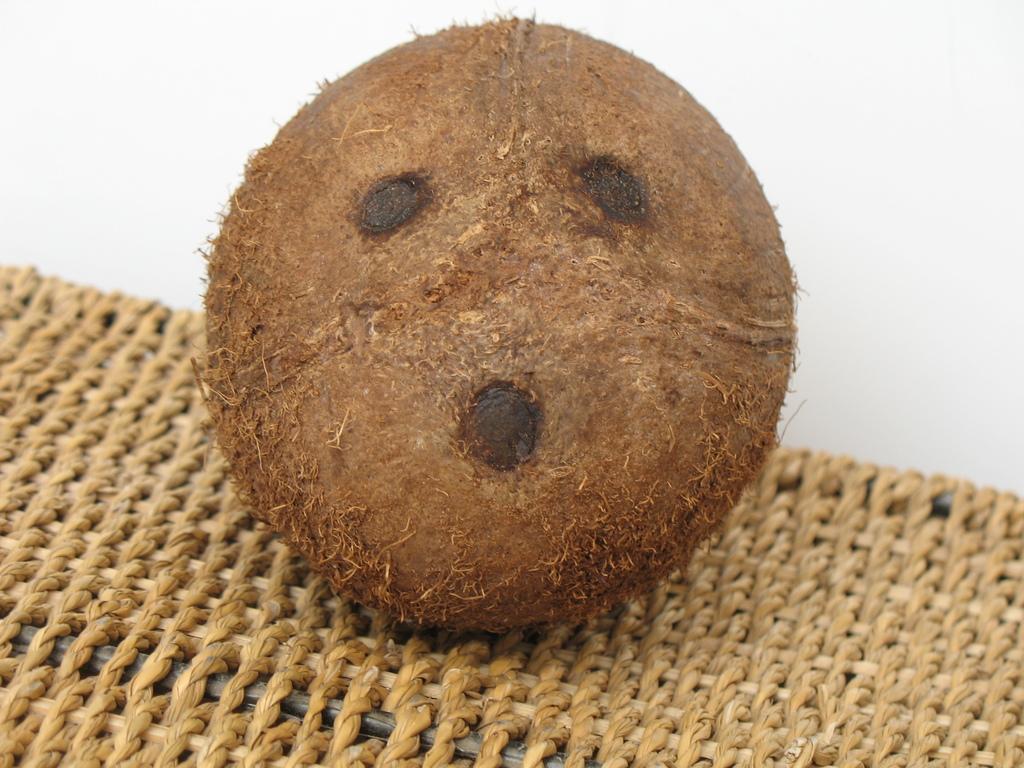In one or two sentences, can you explain what this image depicts? In this image in the center there is one coconut, and at the bottom there is a table and in the background there is a wall. 